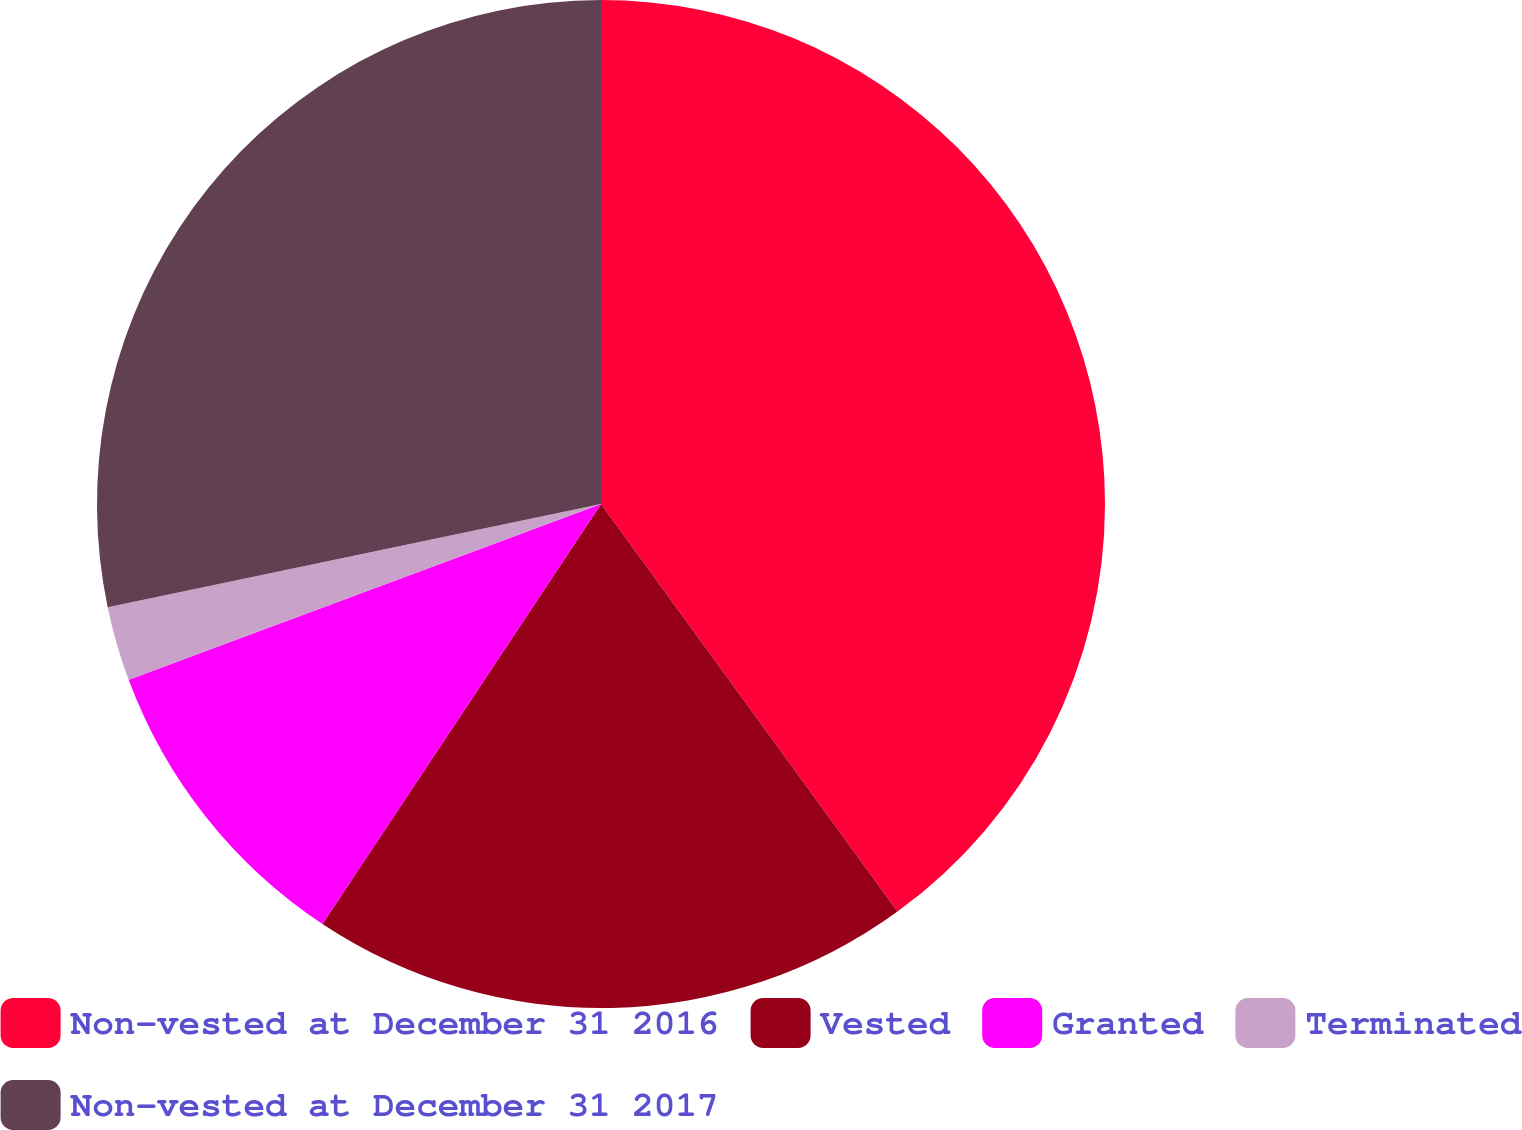Convert chart to OTSL. <chart><loc_0><loc_0><loc_500><loc_500><pie_chart><fcel>Non-vested at December 31 2016<fcel>Vested<fcel>Granted<fcel>Terminated<fcel>Non-vested at December 31 2017<nl><fcel>39.99%<fcel>19.33%<fcel>10.01%<fcel>2.39%<fcel>28.28%<nl></chart> 